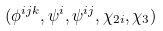Convert formula to latex. <formula><loc_0><loc_0><loc_500><loc_500>( \phi ^ { i j k } , \psi ^ { i } , \psi ^ { i j } , \chi _ { 2 i } , \chi _ { 3 } )</formula> 